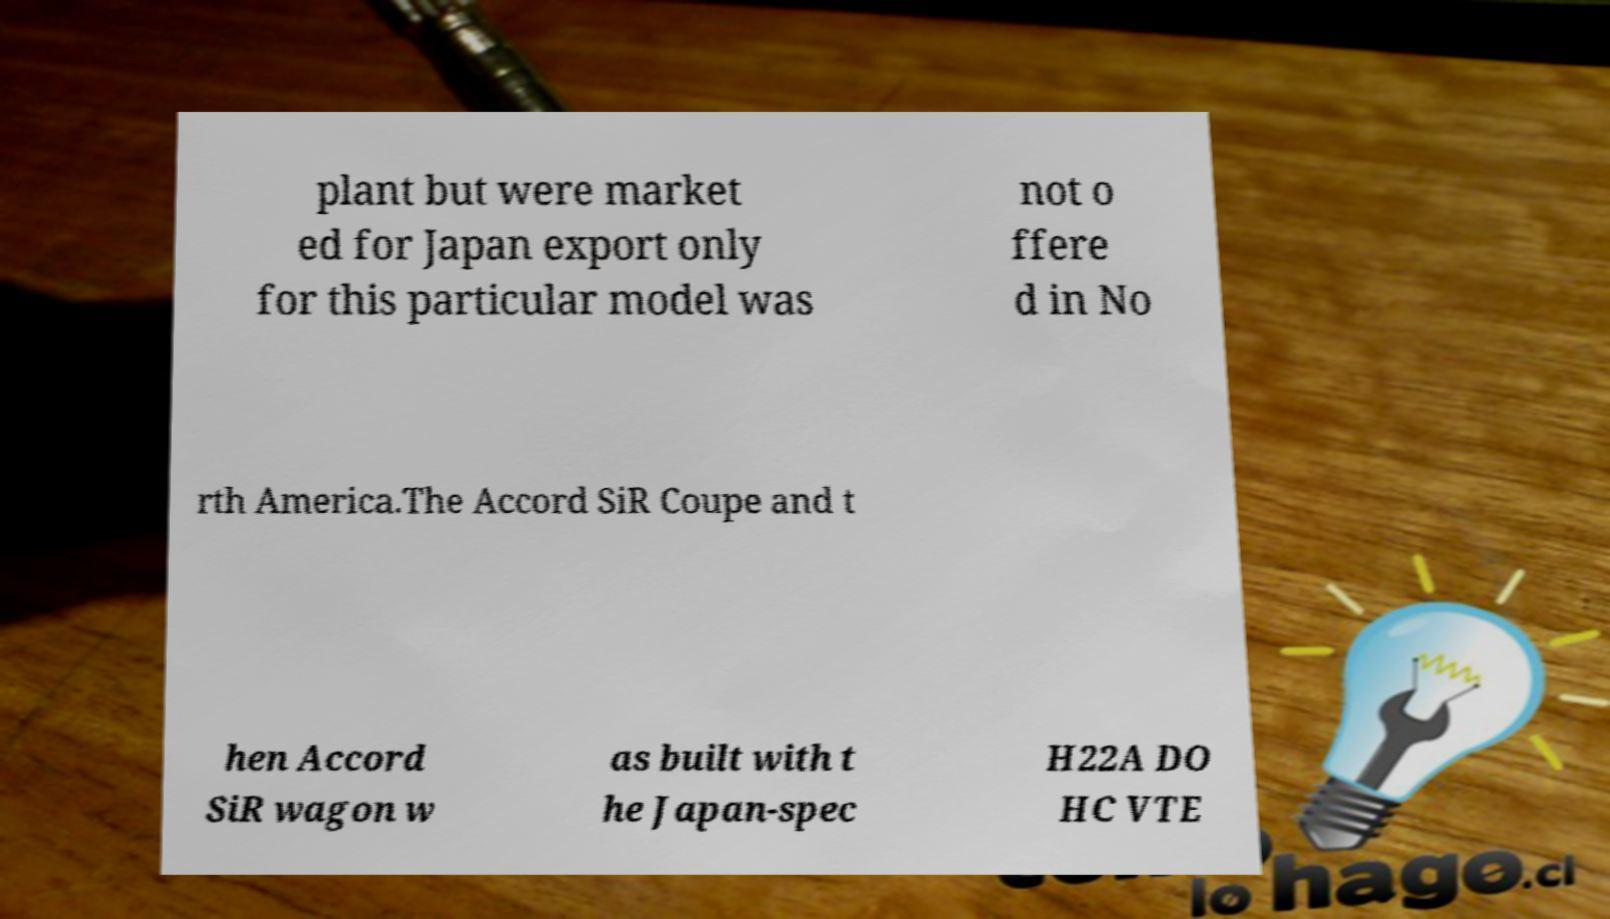Please read and relay the text visible in this image. What does it say? plant but were market ed for Japan export only for this particular model was not o ffere d in No rth America.The Accord SiR Coupe and t hen Accord SiR wagon w as built with t he Japan-spec H22A DO HC VTE 